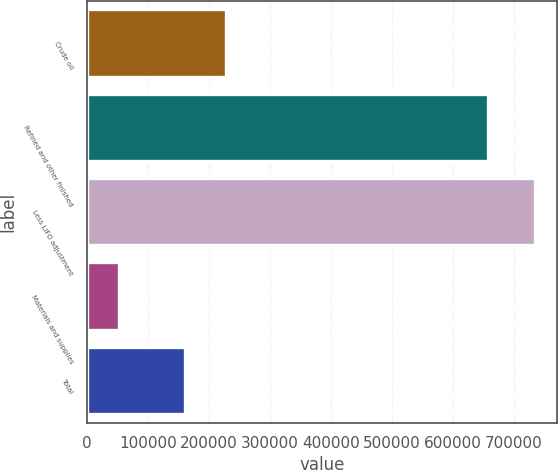Convert chart to OTSL. <chart><loc_0><loc_0><loc_500><loc_500><bar_chart><fcel>Crude oil<fcel>Refined and other finished<fcel>Less LIFO adjustment<fcel>Materials and supplies<fcel>Total<nl><fcel>227760<fcel>657914<fcel>734177<fcel>52512<fcel>159594<nl></chart> 